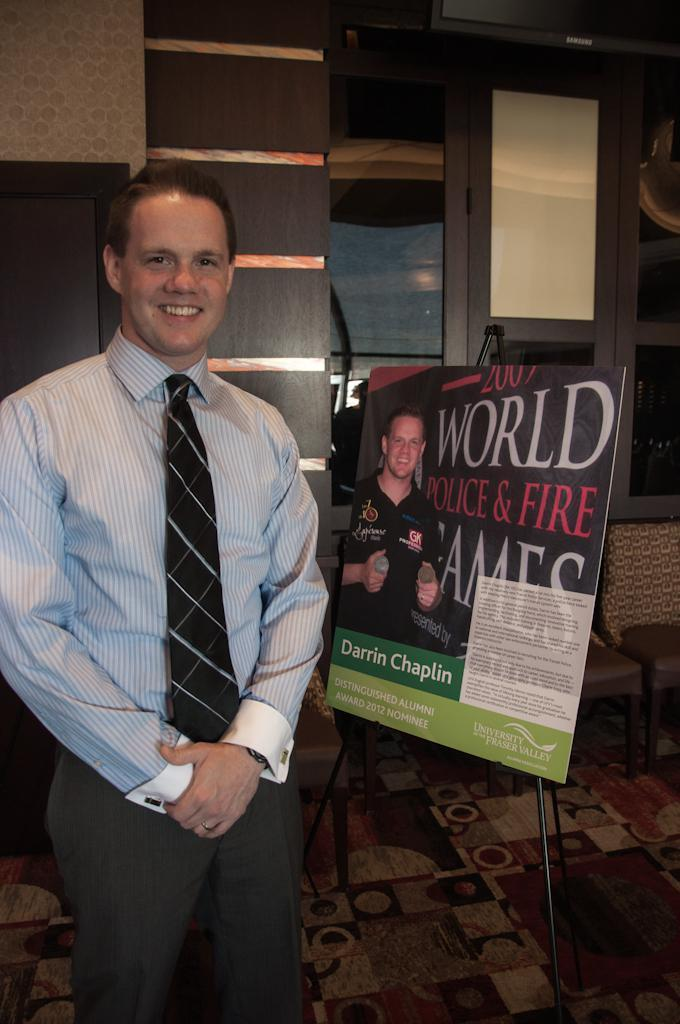What is the man in the image doing? The man is standing in the image. Where is the man standing? The man is standing on the floor. What is the man's facial expression? The man is smiling. What can be seen on the wall in the image? There is a board in the image. What type of furniture is present in the image? There are chairs in the image. What objects can be seen on the table in the image? There are glasses in the image. What is the background of the image? There is a wall in the image. What historical event is the man guiding in the image? There is no historical event or guide present in the image; it simply shows a man standing and smiling. 